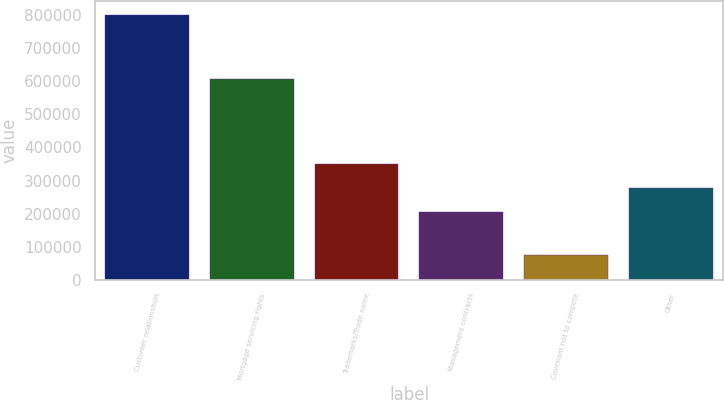Convert chart to OTSL. <chart><loc_0><loc_0><loc_500><loc_500><bar_chart><fcel>Customer relationships<fcel>Mortgage servicing rights<fcel>Trademarks/Trade name<fcel>Management contracts<fcel>Covenant not to compete<fcel>Other<nl><fcel>802597<fcel>608757<fcel>349060<fcel>203291<fcel>73750<fcel>276176<nl></chart> 